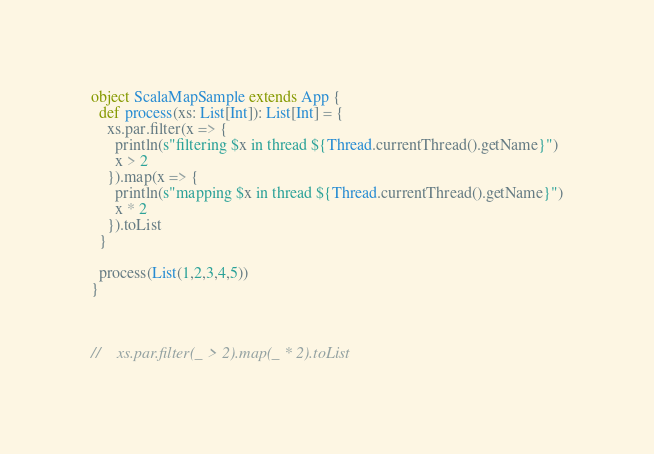Convert code to text. <code><loc_0><loc_0><loc_500><loc_500><_Scala_>object ScalaMapSample extends App {
  def process(xs: List[Int]): List[Int] = {
    xs.par.filter(x => {
      println(s"filtering $x in thread ${Thread.currentThread().getName}")
      x > 2
    }).map(x => {
      println(s"mapping $x in thread ${Thread.currentThread().getName}")
      x * 2
    }).toList
  }

  process(List(1,2,3,4,5))
}



//    xs.par.filter(_ > 2).map(_ * 2).toList
</code> 